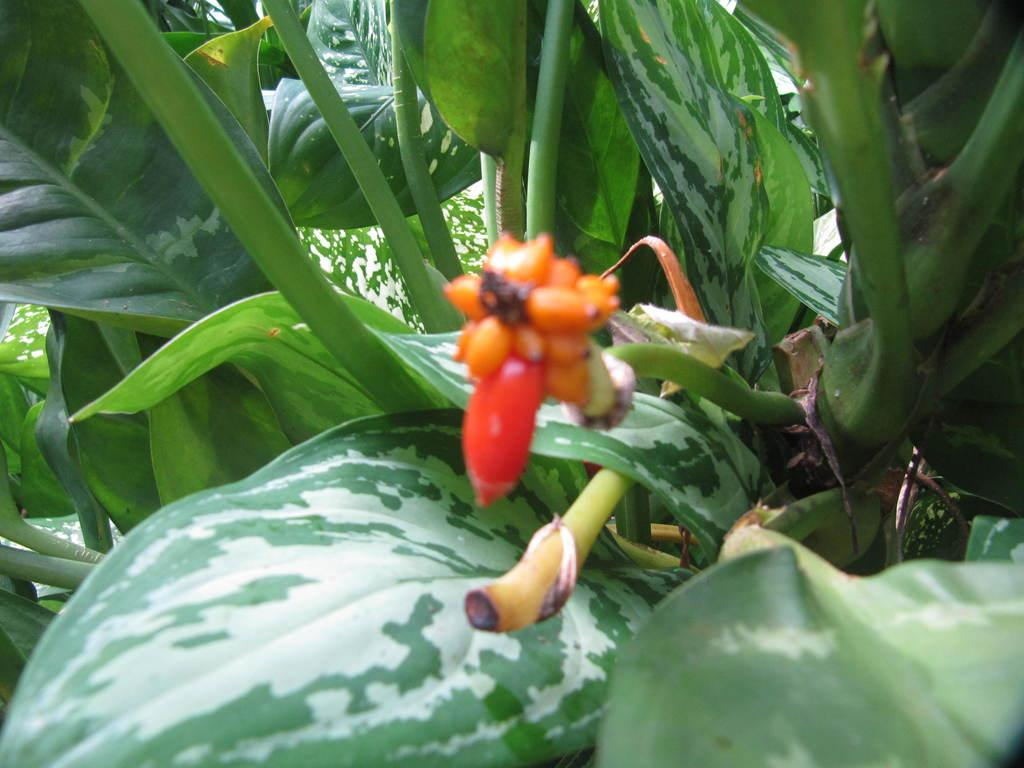What types of living organisms can be seen in the image? Plants can be seen in the image. What is the main focus of the image? There is a flower in the center of the image. What type of kitty can be seen playing with a note in the image? There is no kitty or note present in the image; it only contains plants and a flower. 